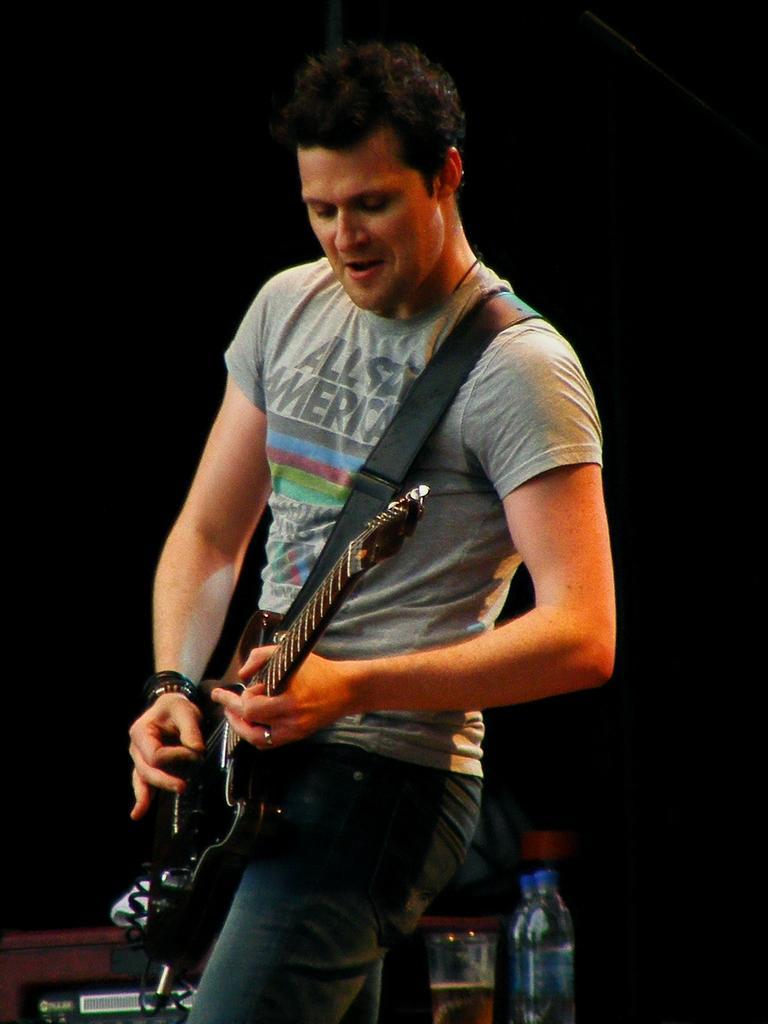Can you describe this image briefly? In this image I see a man who is holding a guitar. In the background I see a glass and bottles. 